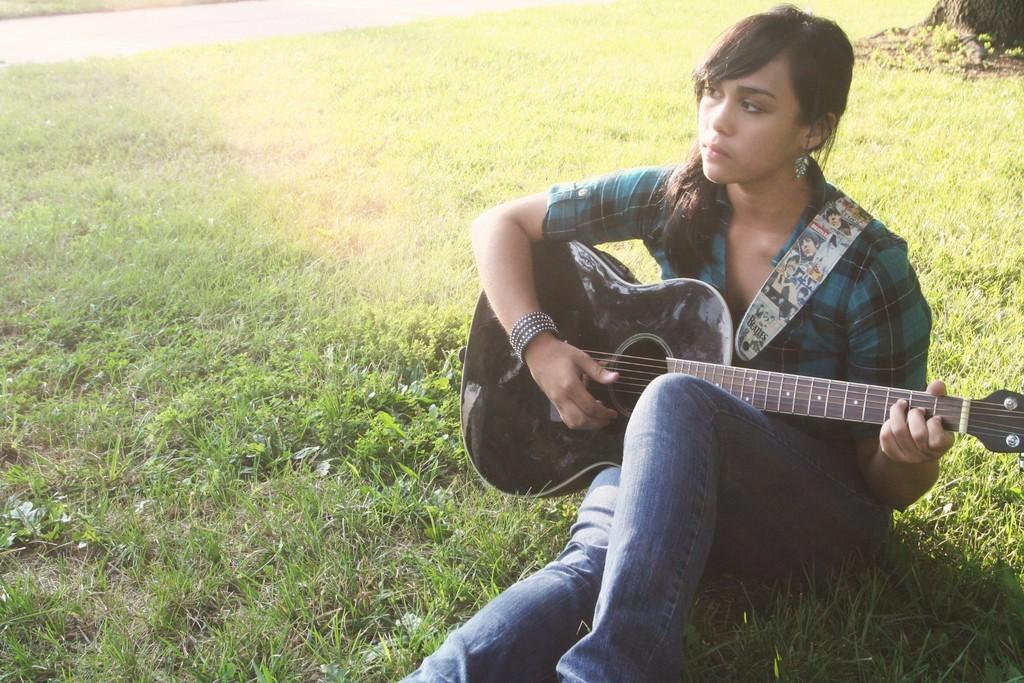Who is the main subject in the image? There is a woman in the image. What is the woman holding in the image? The woman is holding a guitar. What color is the woman's shirt in the image? The woman is wearing a green shirt. What color are the woman's pants in the image? The woman is wearing blue pants. What type of natural environment is visible in the image? There is grass visible in the image. What type of object can be seen in the image that is not a part of the woman or her clothing? There is a tree trunk in the image. What type of toy can be seen on the road in the image? There is no road or toy present in the image. What is the plot of the story being told in the image? The image does not depict a story or plot; it is a snapshot of a woman holding a guitar. 